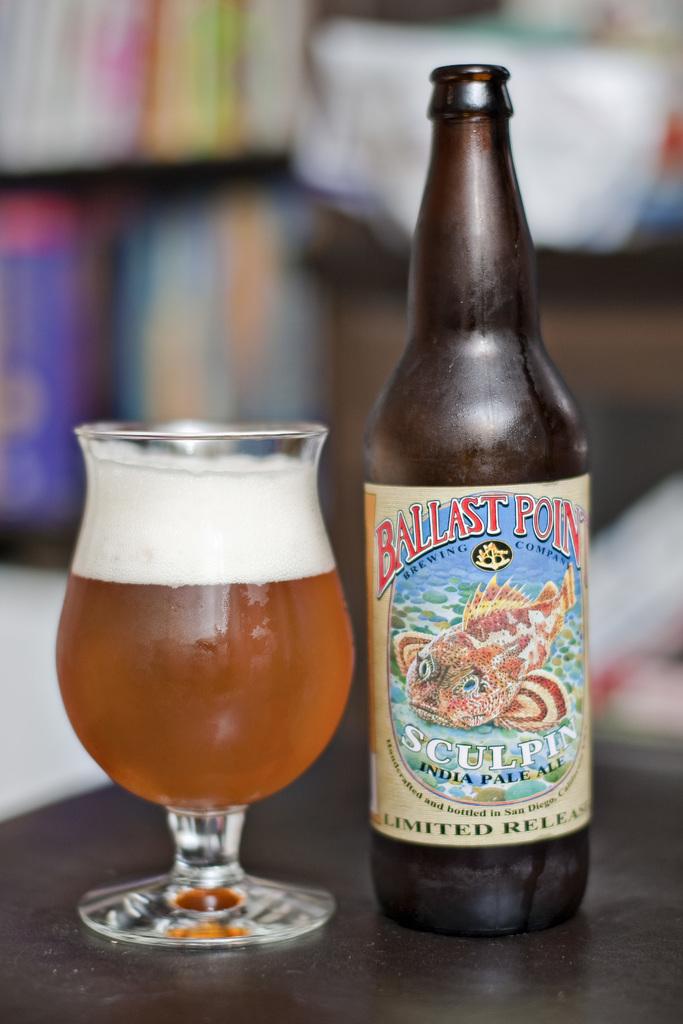What brewing company made this delicious beer?
Your response must be concise. Ballast point. What is this beer?
Offer a very short reply. Ballast point. 